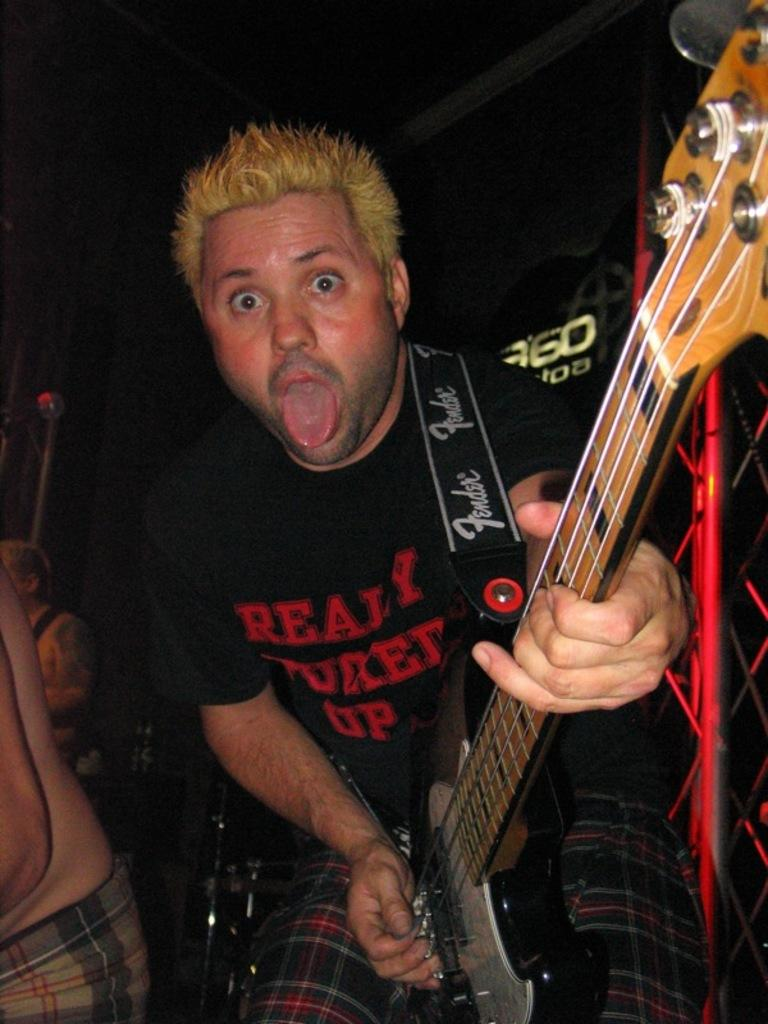What is the person in the image doing? The person is playing a guitar. What is the person wearing in the image? The person is wearing a black shirt. How many other people are present in the image? There are two other people beside the person playing the guitar. What type of board is the person using to play the guitar in the image? There is no board present in the image. 